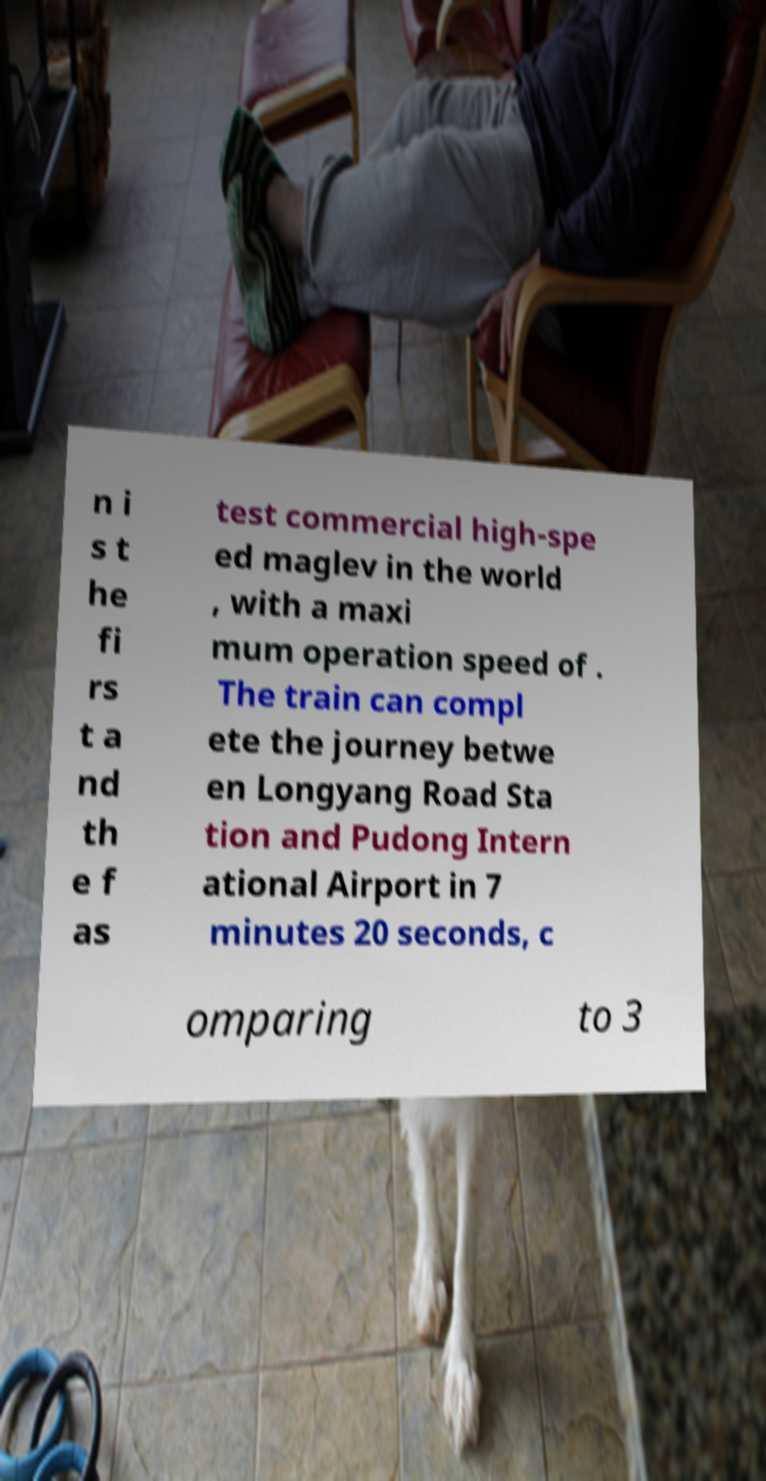Please read and relay the text visible in this image. What does it say? n i s t he fi rs t a nd th e f as test commercial high-spe ed maglev in the world , with a maxi mum operation speed of . The train can compl ete the journey betwe en Longyang Road Sta tion and Pudong Intern ational Airport in 7 minutes 20 seconds, c omparing to 3 